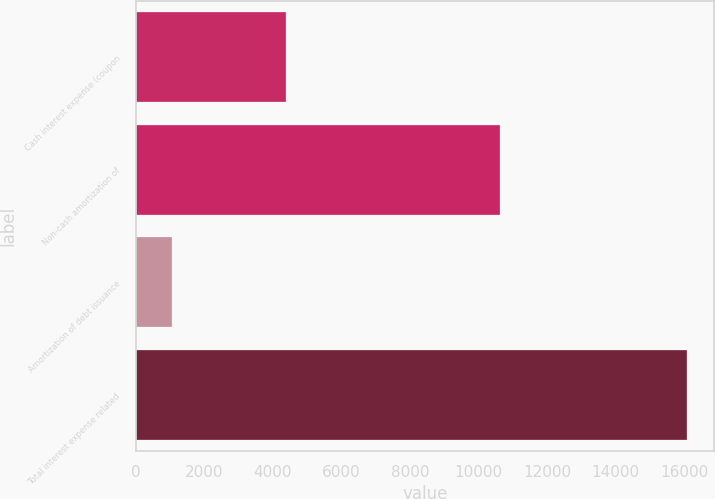Convert chart to OTSL. <chart><loc_0><loc_0><loc_500><loc_500><bar_chart><fcel>Cash interest expense (coupon<fcel>Non-cash amortization of<fcel>Amortization of debt issuance<fcel>Total interest expense related<nl><fcel>4375<fcel>10639<fcel>1054<fcel>16068<nl></chart> 